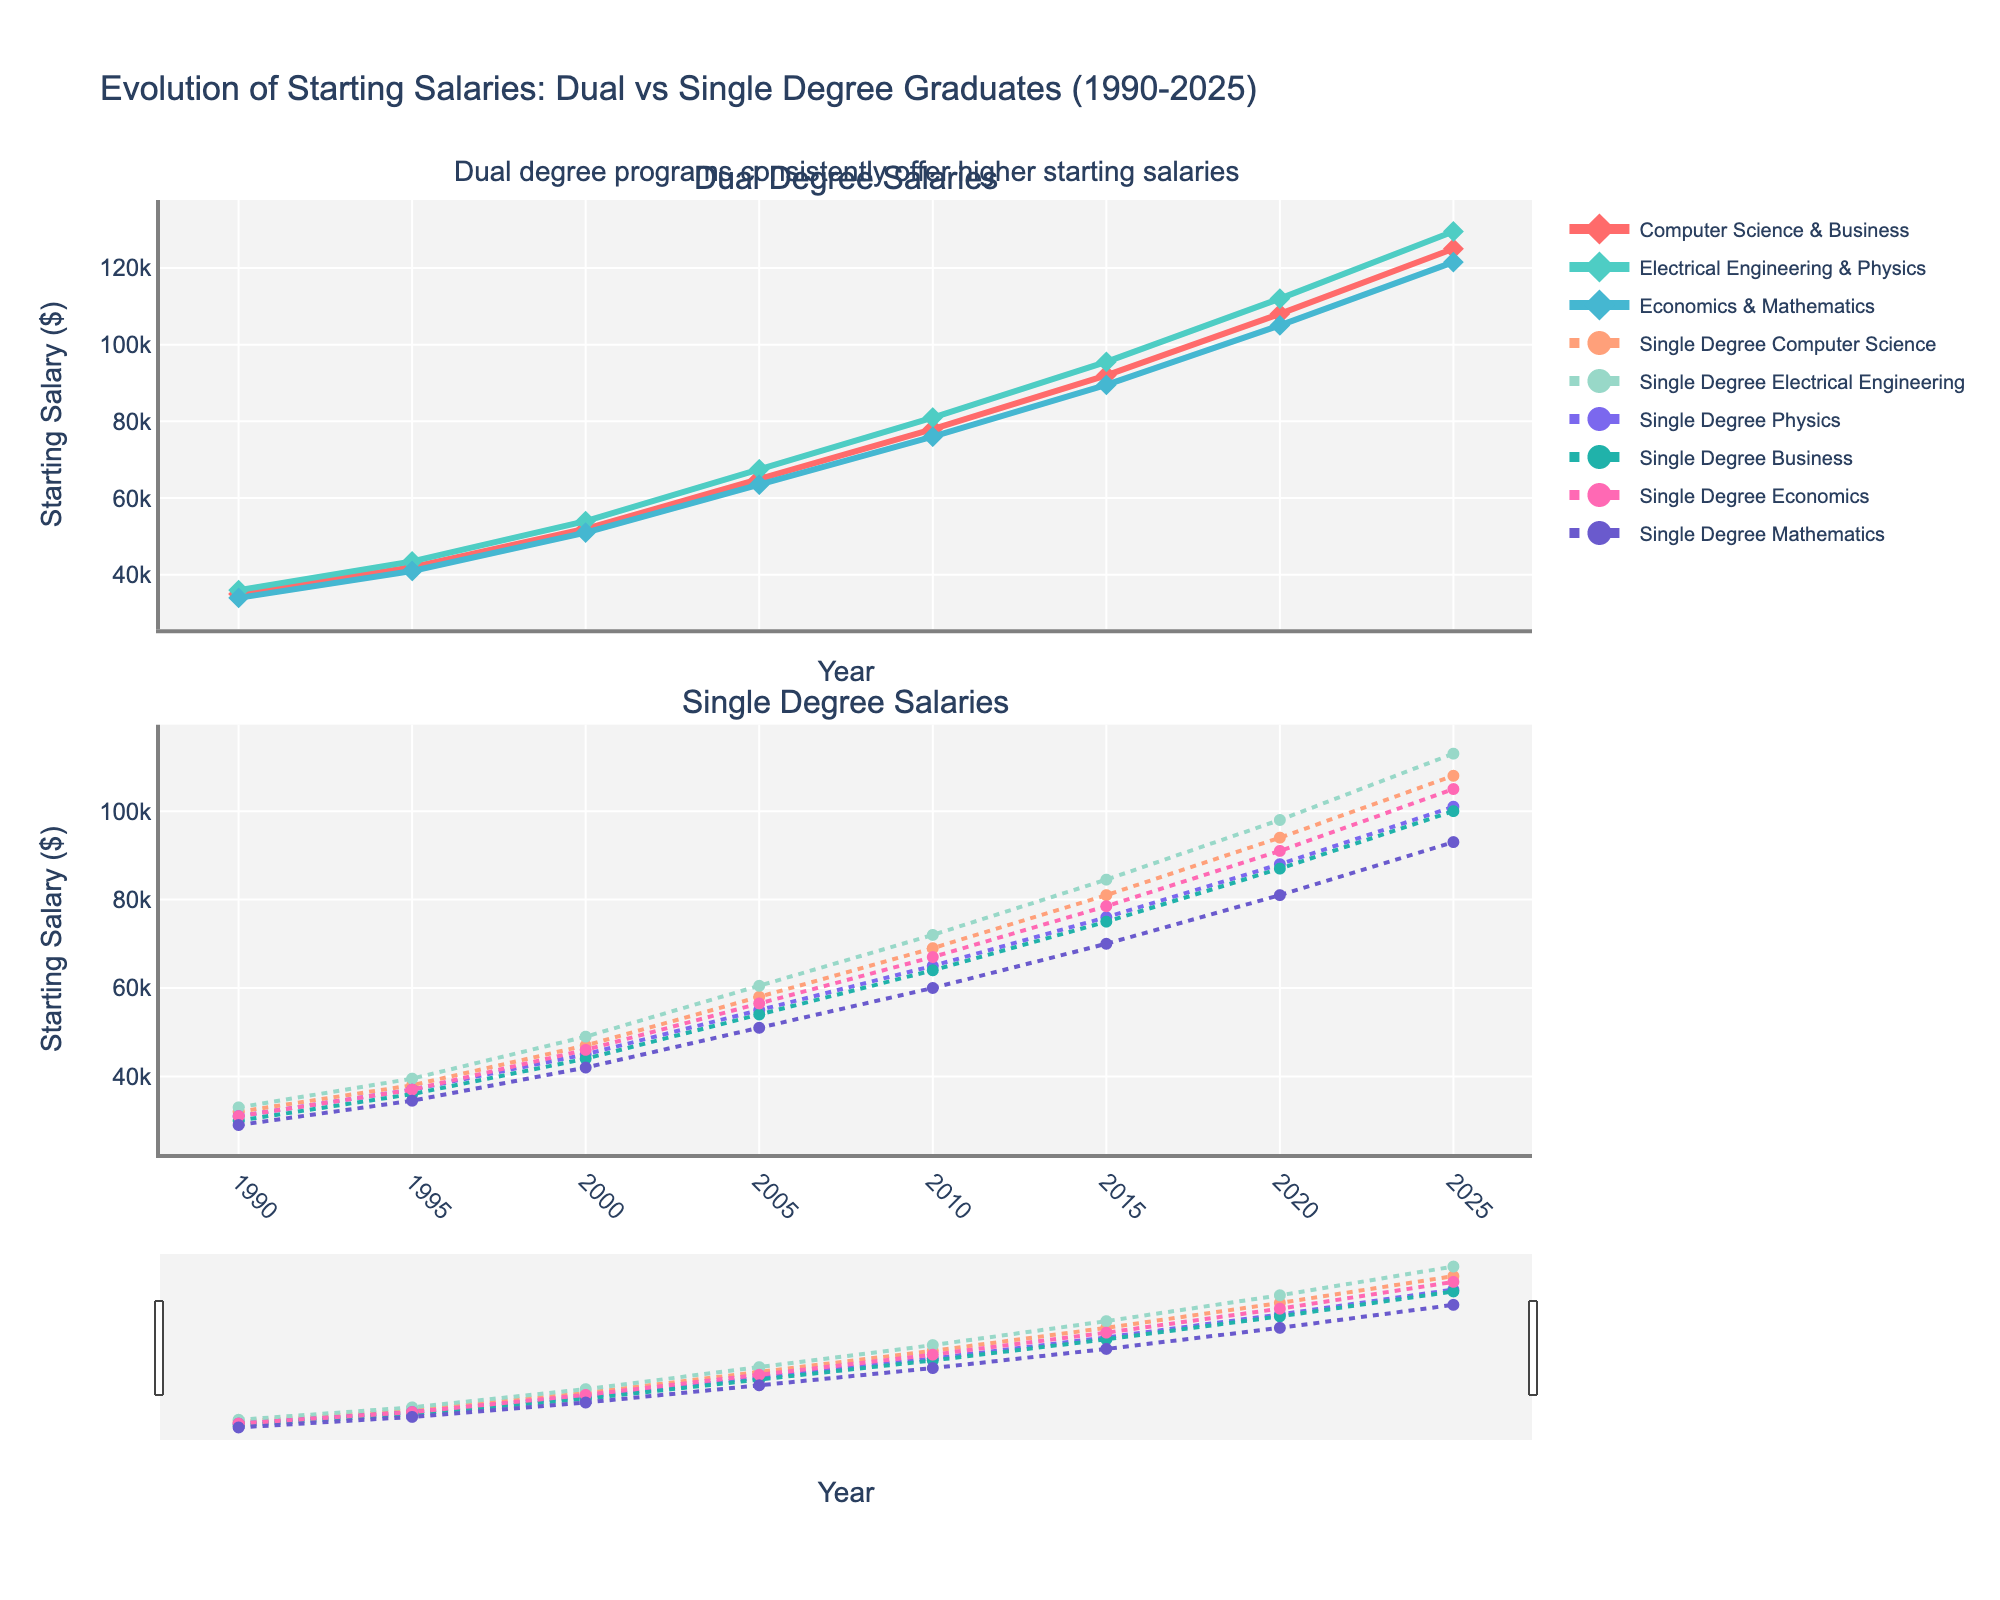What trend do you observe in starting salaries for dual degree and single degree holders from 1990 to 2025? Examine the line chart for both dual degree and single degree holders from 1990 to 2025. Both sets of lines show an upward trend, indicating an overall increase in starting salaries over the years.
Answer: Upward trend Between 1990 and 2025, which dual degree combination experienced the highest increase in starting salary? Compare the increase in starting salaries for 'Computer Science & Business', 'Electrical Engineering & Physics', and 'Economics & Mathematics' by taking the difference between their 2025 and 1990 values. Electrical Engineering & Physics increased the most (129500 - 36000 = 93500).
Answer: Electrical Engineering & Physics In what year did the starting salary for dual degree holders in 'Economics & Mathematics' cross $100,000? Look at the line for 'Economics & Mathematics' and identify the year where the salary first exceeds $100,000. This occurs between 2020 and 2025, with the first instance recorded in 2025.
Answer: 2025 How does the 2025 starting salary for single degree Electrical Engineering compare to dual degree Electrical Engineering & Physics? Compare the 2025 salary values for 'Single Degree Electrical Engineering' (113000) and 'Electrical Engineering & Physics' (129500). The dual degree has a higher salary in 2025.
Answer: Dual degree higher Which degree combination had the smallest salary difference between dual degree and single degree holders in the year 2000? Calculate the difference between the dual degree salary and corresponding single degree salaries for 2000. The smallest difference is in Computer Science, where (52000 - 47000) = 5000.
Answer: Computer Science Which field showed the largest salary gap between dual degrees and single degrees in 2020? Calculate the absolute difference for each pair of fields in 2020. Electrical Engineering & Physics (112000 - 98000 = 14000) has the largest salary gap.
Answer: Electrical Engineering How has the difference between dual degree and single degree starting salaries for Computer Science evolved from 1990 to 2025? Calculate the differences for each year: 1990 (35000 - 32000 = 3000), 1995 (42000 - 38000 = 4000), 2000 (52000 - 47000 = 5000), 2005 (65000 - 58000 = 7000), 2010 (78000 - 69000 = 9000), 2015 (92000 - 81000 = 11000), 2020 (108000 - 94000 = 14000), and 2025 (125000 - 108000 = 17000). The gap has been increasing over the years.
Answer: Increasing Which single degree field has the highest starting salary in 2015? Look at the line chart for single degrees in 2015 and identify the field with the highest value. Electrical Engineering has the highest starting salary at 84500.
Answer: Electrical Engineering From the visual chart, which colored line represents the starting salary data for 'Computer Science & Business'? Identify the color of the line corresponding to 'Computer Science & Business' in the top subplot, noted in the legend. The line is represented by the red color.
Answer: Red 